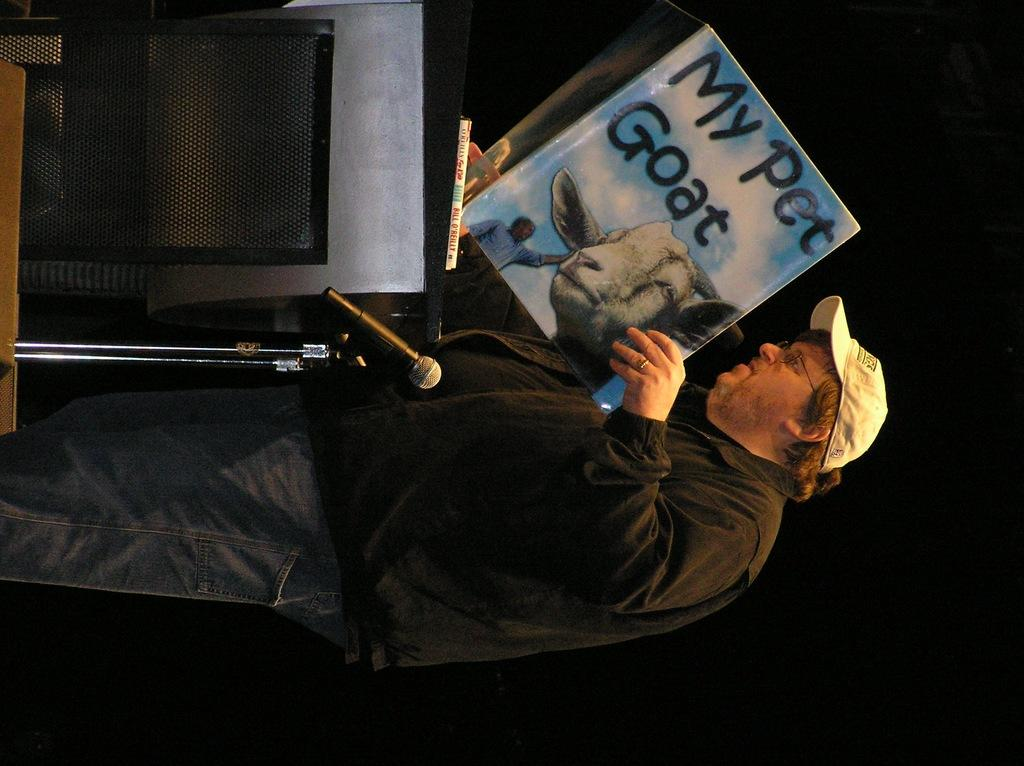<image>
Present a compact description of the photo's key features. A man is standing at a podium with reading aloud the book My Pet Goat. 